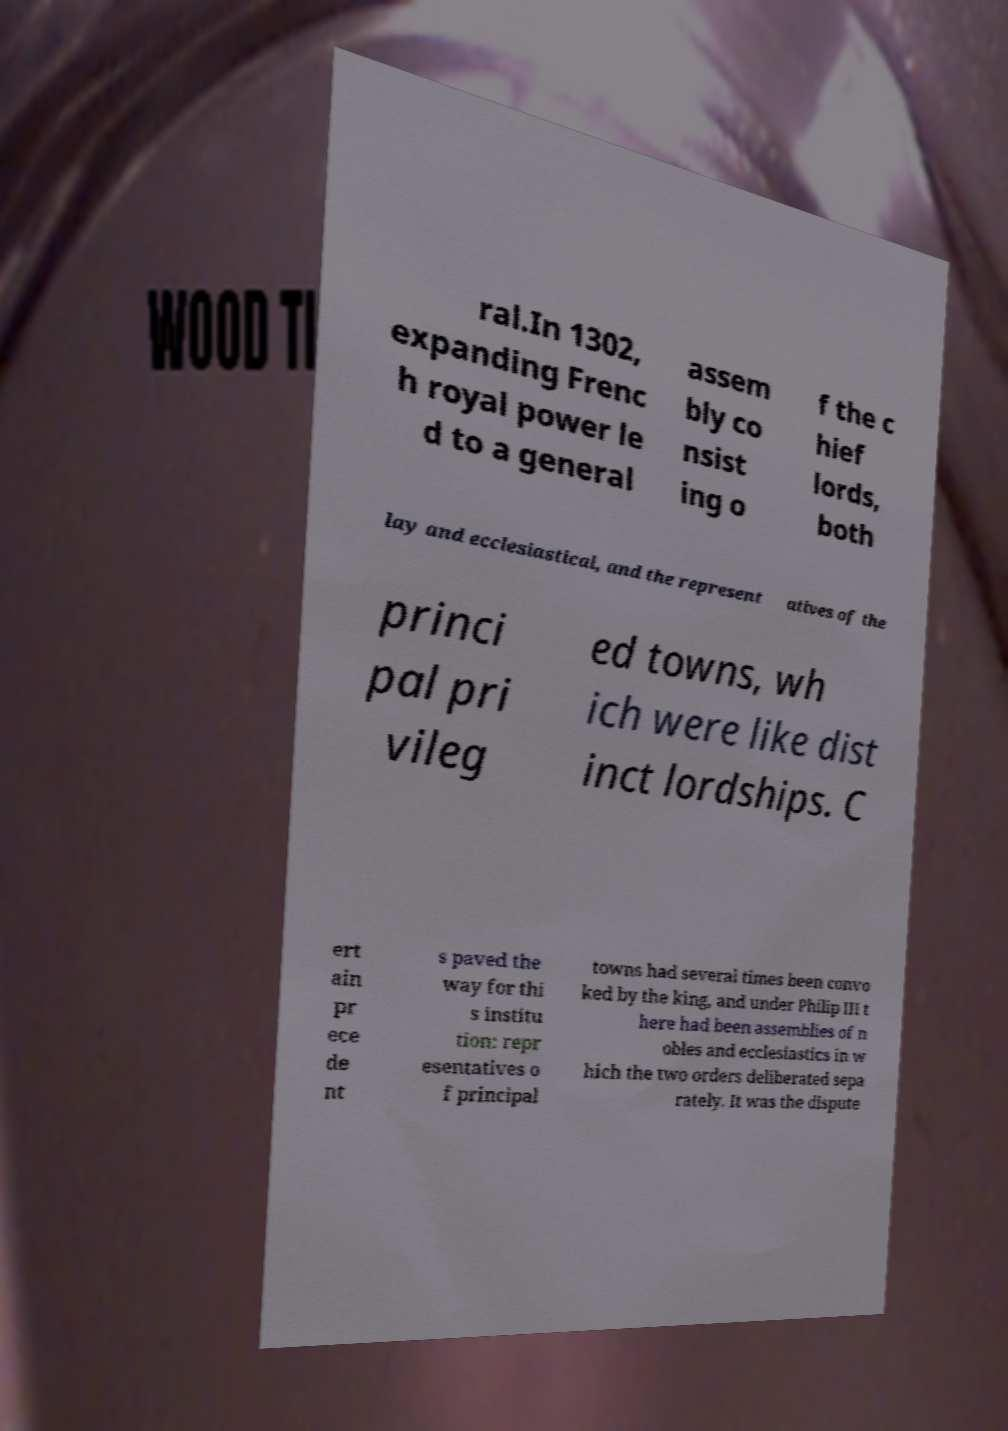Can you read and provide the text displayed in the image?This photo seems to have some interesting text. Can you extract and type it out for me? ral.In 1302, expanding Frenc h royal power le d to a general assem bly co nsist ing o f the c hief lords, both lay and ecclesiastical, and the represent atives of the princi pal pri vileg ed towns, wh ich were like dist inct lordships. C ert ain pr ece de nt s paved the way for thi s institu tion: repr esentatives o f principal towns had several times been convo ked by the king, and under Philip III t here had been assemblies of n obles and ecclesiastics in w hich the two orders deliberated sepa rately. It was the dispute 